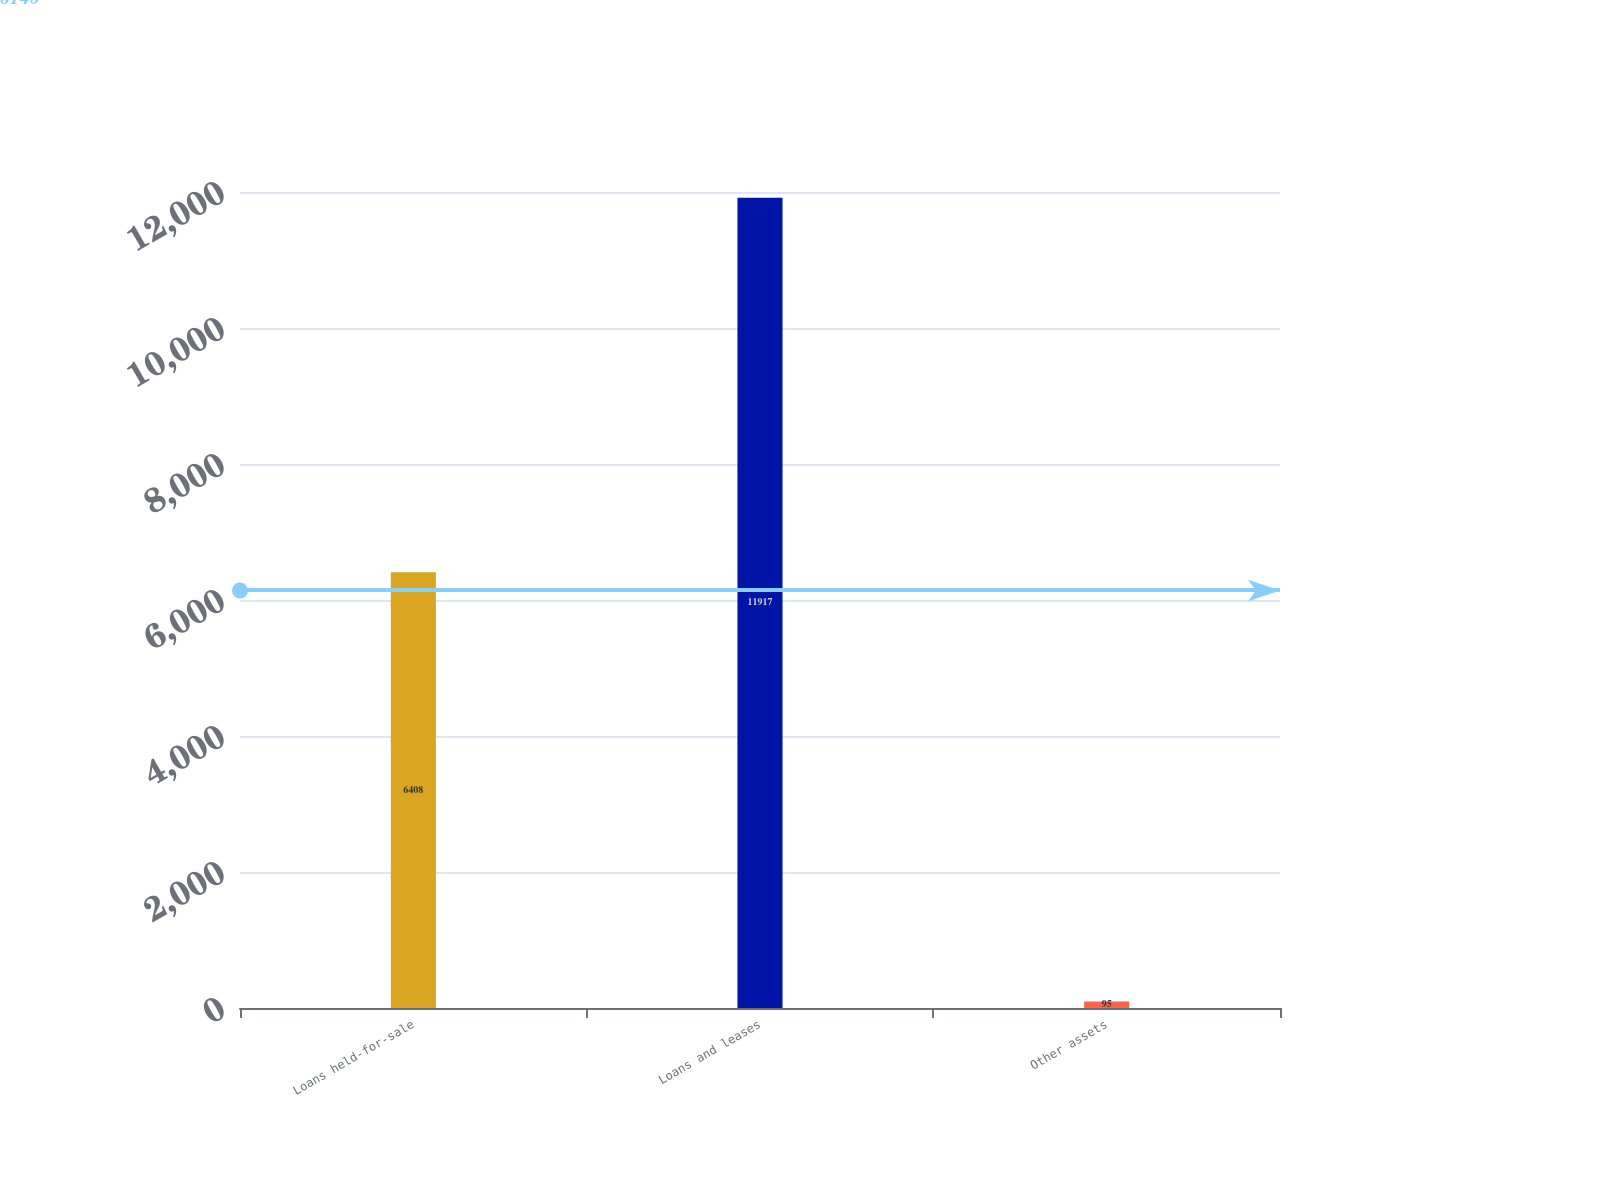Convert chart to OTSL. <chart><loc_0><loc_0><loc_500><loc_500><bar_chart><fcel>Loans held-for-sale<fcel>Loans and leases<fcel>Other assets<nl><fcel>6408<fcel>11917<fcel>95<nl></chart> 